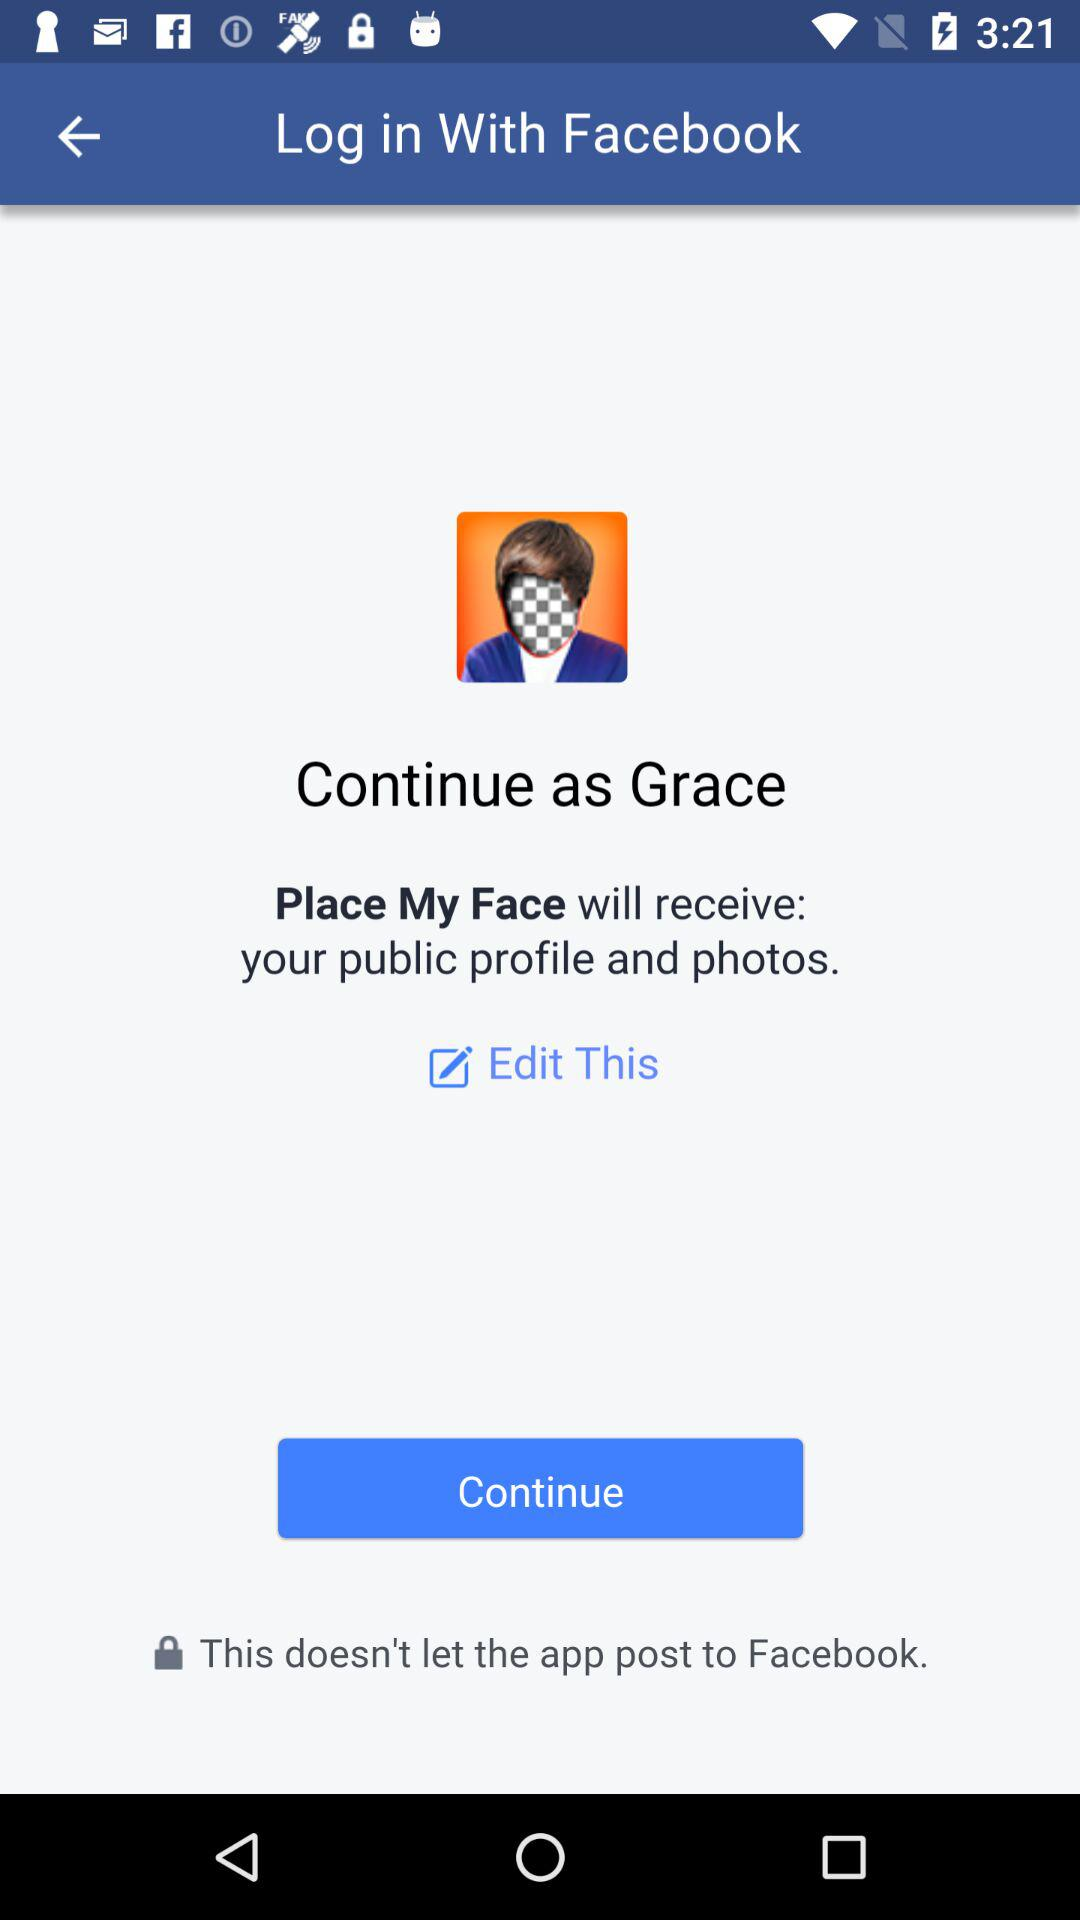Through what application can we log in? You can log in through "Facebook". 